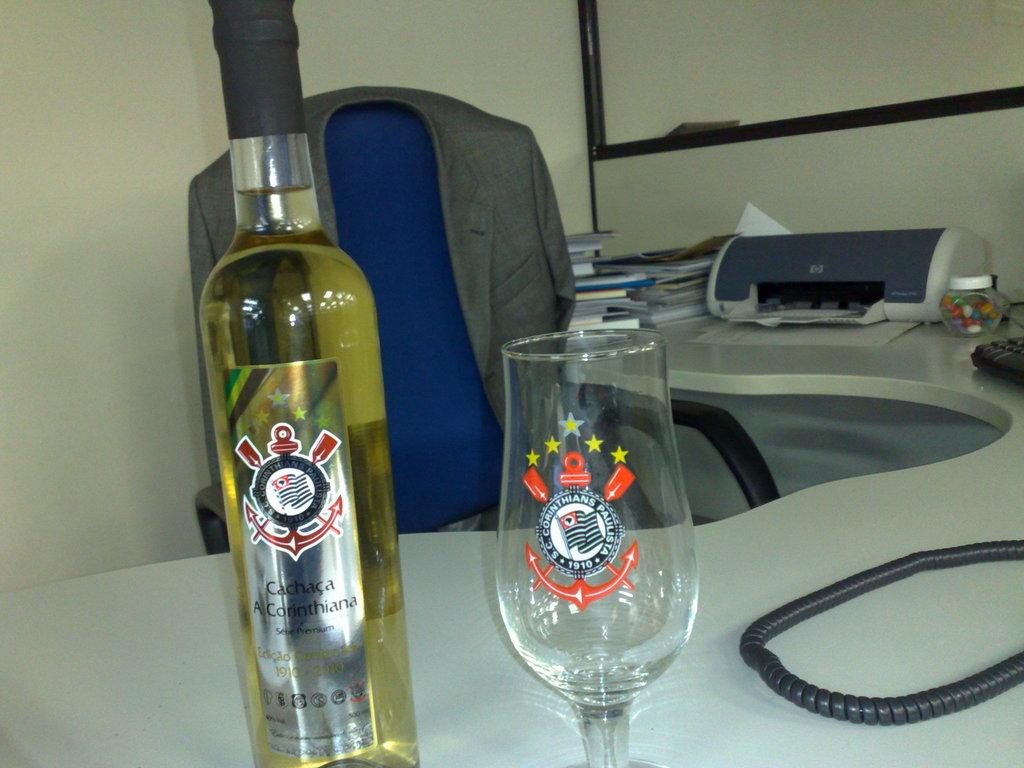<image>
Write a terse but informative summary of the picture. An office desk with a bottle of Cachaca and a decorative glass. 